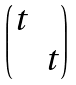Convert formula to latex. <formula><loc_0><loc_0><loc_500><loc_500>\begin{pmatrix} t \\ & t \end{pmatrix}</formula> 